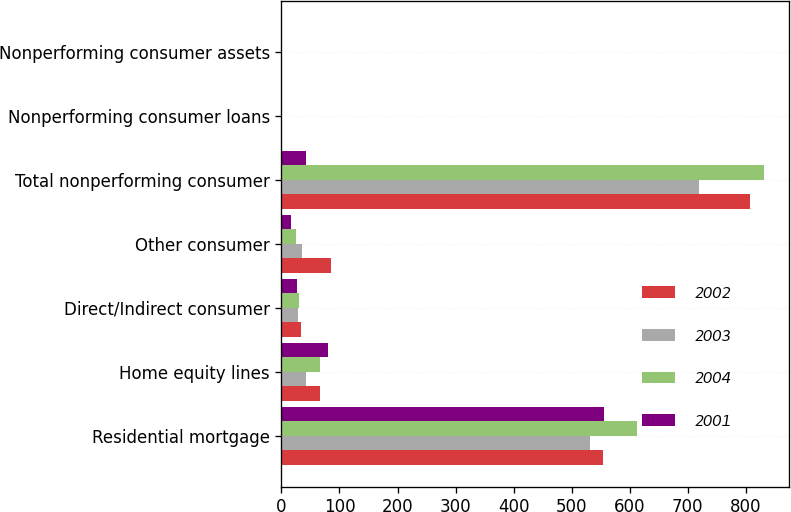Convert chart to OTSL. <chart><loc_0><loc_0><loc_500><loc_500><stacked_bar_chart><ecel><fcel>Residential mortgage<fcel>Home equity lines<fcel>Direct/Indirect consumer<fcel>Other consumer<fcel>Total nonperforming consumer<fcel>Nonperforming consumer loans<fcel>Nonperforming consumer assets<nl><fcel>2002<fcel>554<fcel>66<fcel>33<fcel>85<fcel>807<fcel>0.23<fcel>0.25<nl><fcel>2003<fcel>531<fcel>43<fcel>28<fcel>36<fcel>719<fcel>0.27<fcel>0.3<nl><fcel>2004<fcel>612<fcel>66<fcel>30<fcel>25<fcel>832<fcel>0.37<fcel>0.42<nl><fcel>2001<fcel>556<fcel>80<fcel>27<fcel>16<fcel>43<fcel>0.41<fcel>0.61<nl></chart> 